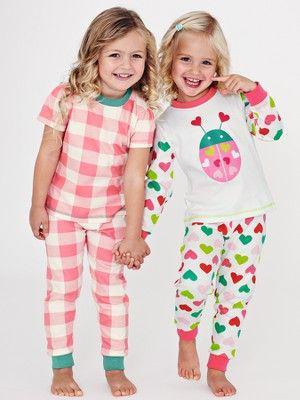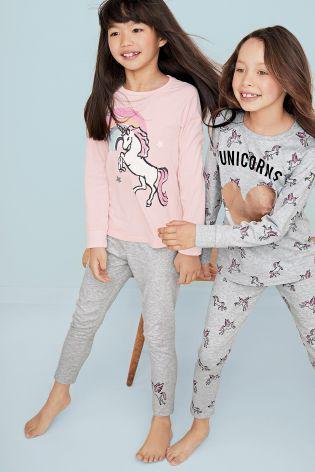The first image is the image on the left, the second image is the image on the right. For the images shown, is this caption "In the left image, the kids are holding each other's hands." true? Answer yes or no. Yes. The first image is the image on the left, the second image is the image on the right. Assess this claim about the two images: "There are two children walking on a bed in one image.". Correct or not? Answer yes or no. No. 